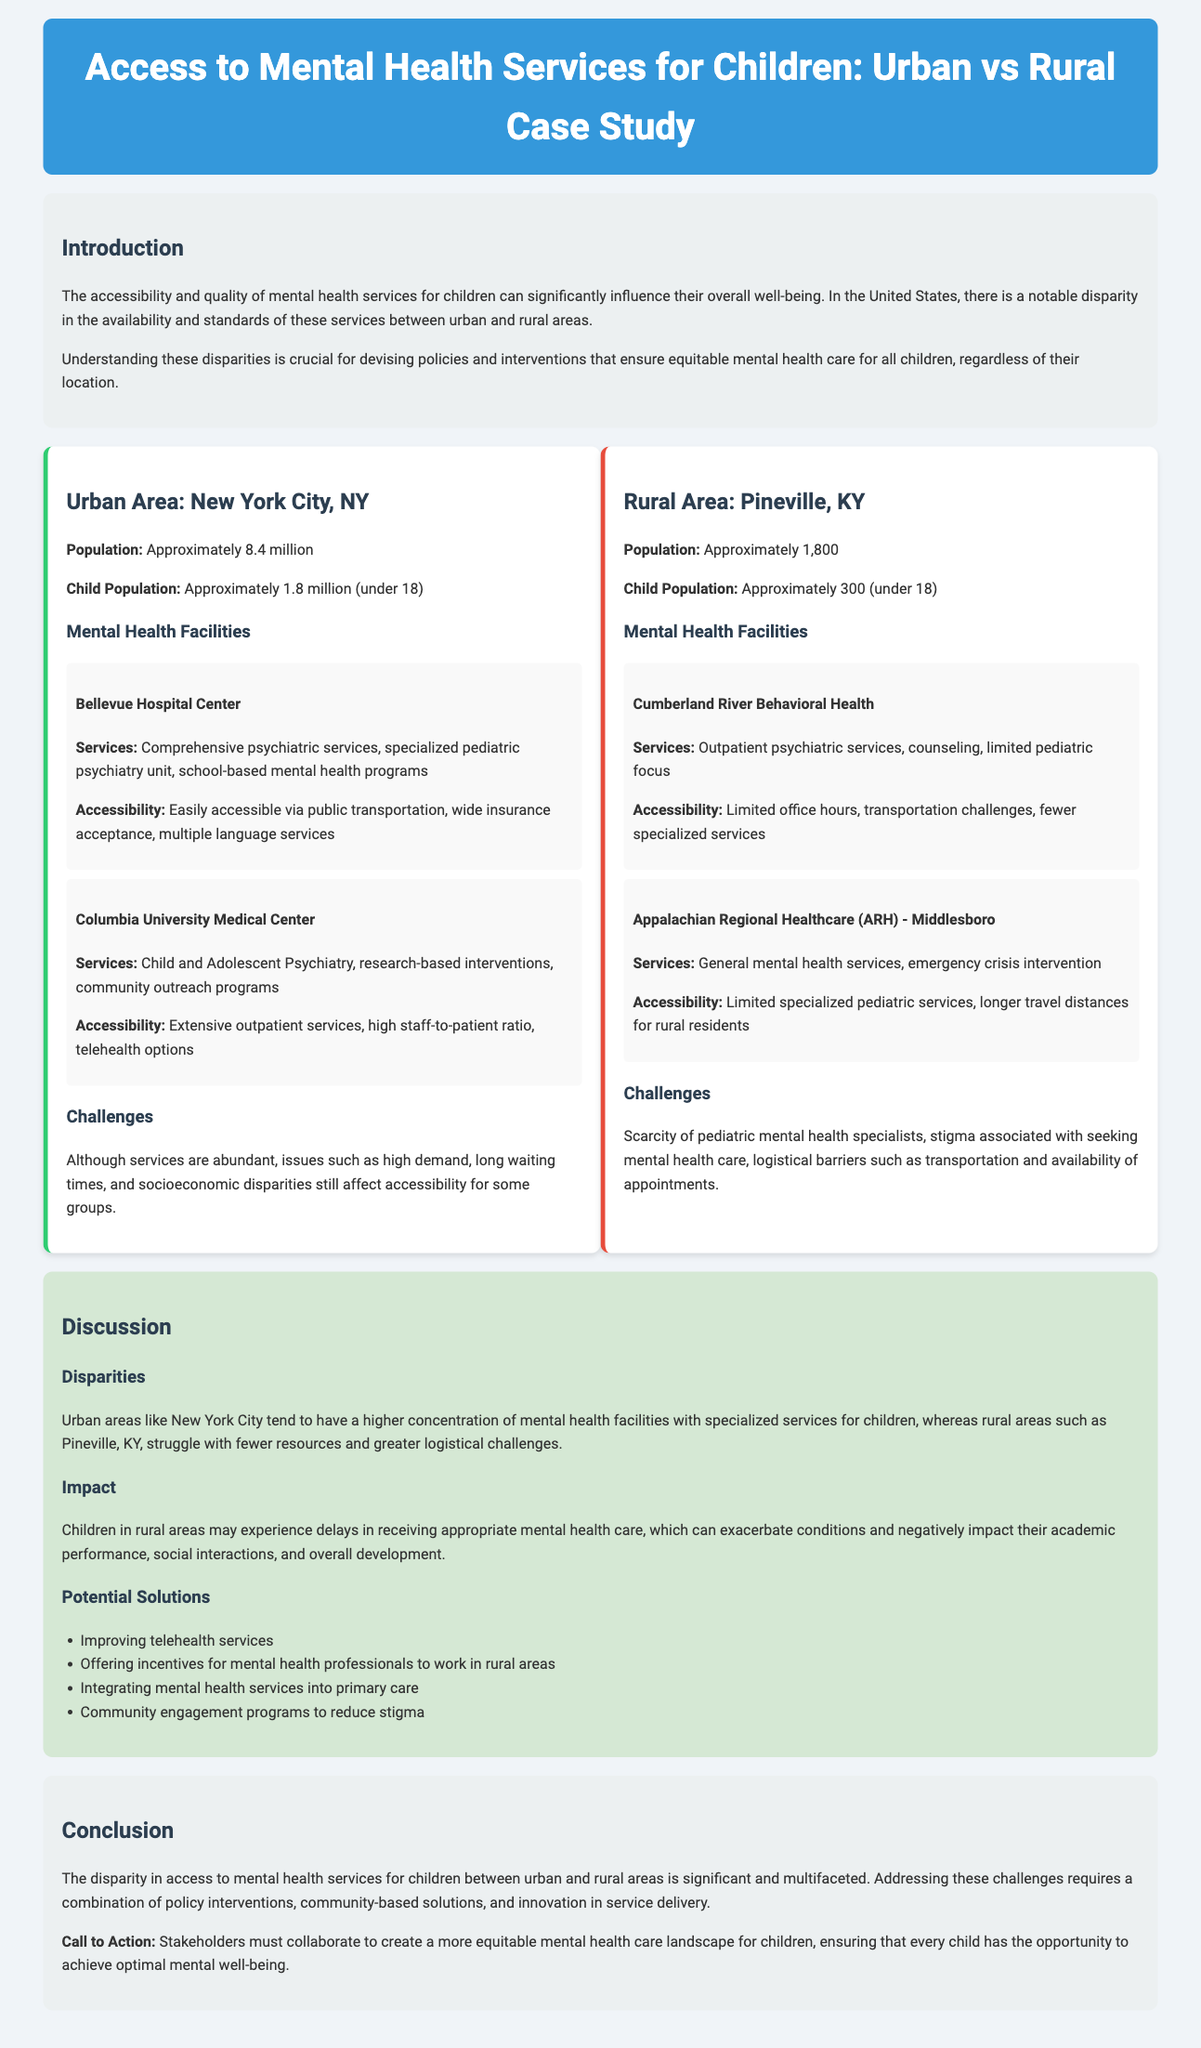what is the population of New York City? The population of New York City is approximately 8.4 million.
Answer: approximately 8.4 million what is the child population in Pineville, KY? The child population in Pineville, KY is approximately 300 (under 18).
Answer: approximately 300 name one mental health facility in urban areas Bellevue Hospital Center is one of the mental health facilities mentioned in the document.
Answer: Bellevue Hospital Center what are the services offered by Cumberland River Behavioral Health? Cumberland River Behavioral Health offers outpatient psychiatric services, counseling, and limited pediatric focus.
Answer: outpatient psychiatric services, counseling, limited pediatric focus what challenge do children in rural areas face regarding mental health care? Children in rural areas may experience delays in receiving appropriate mental health care.
Answer: delays how does accessibility differ between urban and rural areas? Urban areas tend to have a higher concentration of mental health facilities, while rural areas struggle with fewer resources and greater logistical challenges.
Answer: higher concentration of facilities vs. fewer resources what potential solution is suggested to improve mental health services in rural areas? Improving telehealth services is suggested as a potential solution.
Answer: Improving telehealth services which group is likely to experience stigma associated with seeking mental health care? The children in rural areas may experience stigma associated with seeking mental health care.
Answer: children in rural areas 